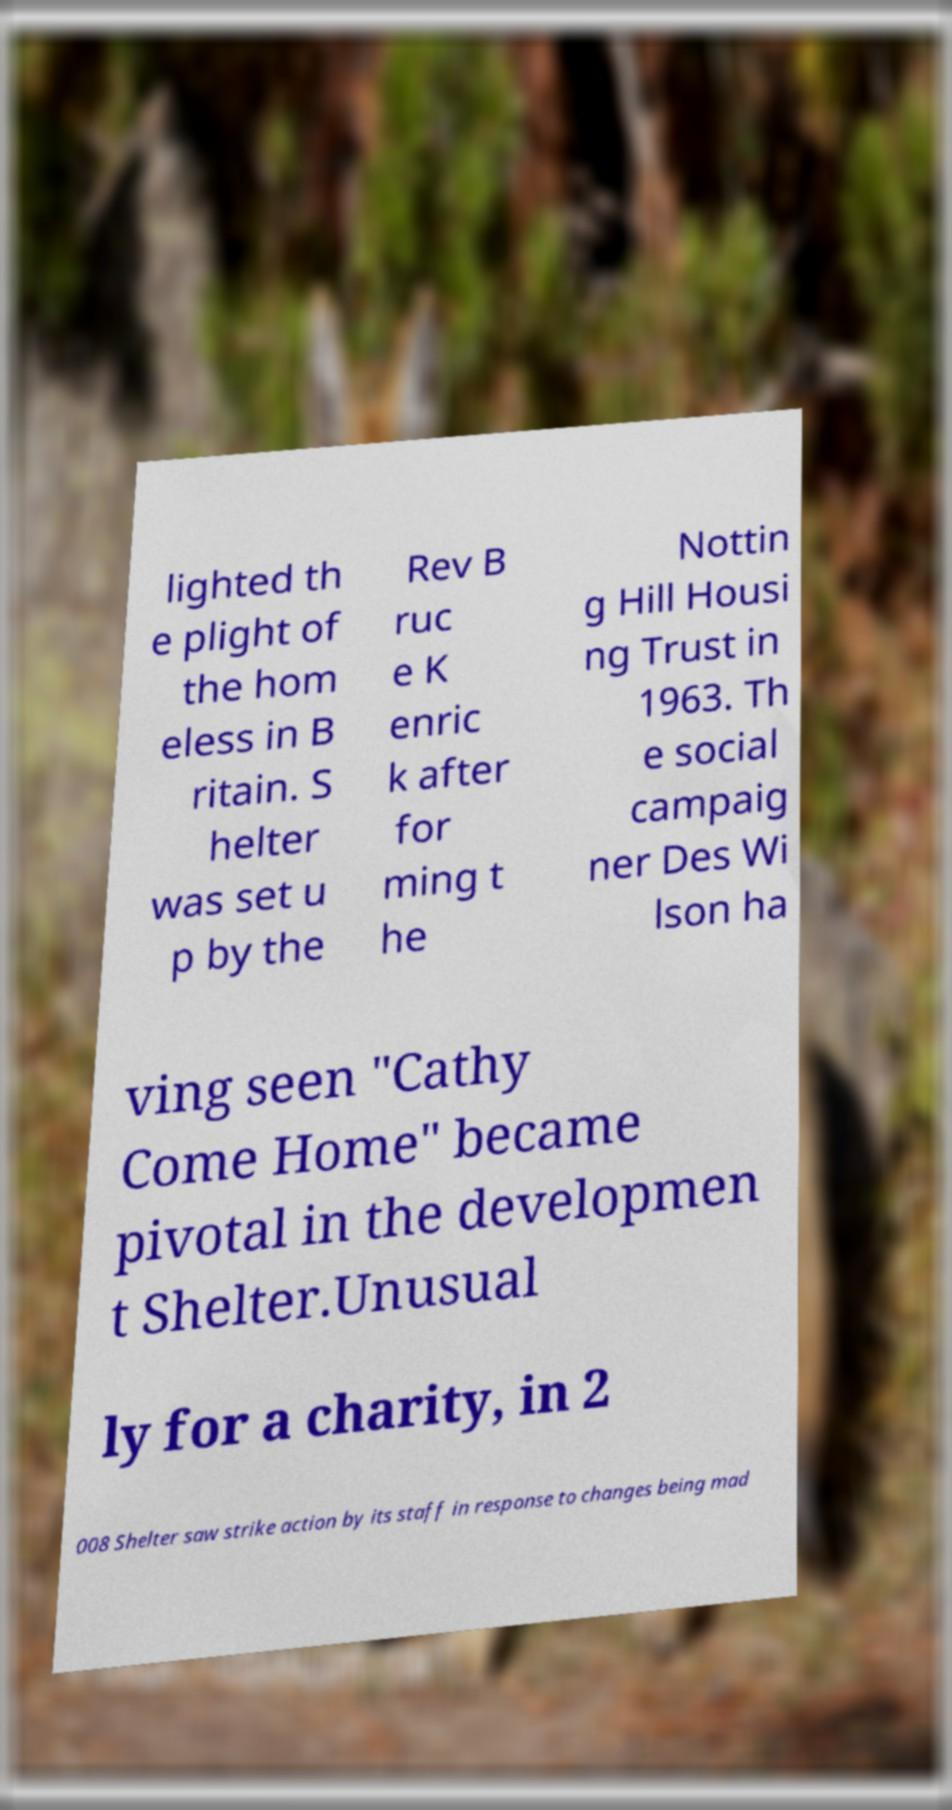Please read and relay the text visible in this image. What does it say? lighted th e plight of the hom eless in B ritain. S helter was set u p by the Rev B ruc e K enric k after for ming t he Nottin g Hill Housi ng Trust in 1963. Th e social campaig ner Des Wi lson ha ving seen "Cathy Come Home" became pivotal in the developmen t Shelter.Unusual ly for a charity, in 2 008 Shelter saw strike action by its staff in response to changes being mad 